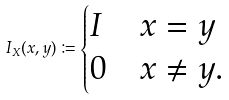<formula> <loc_0><loc_0><loc_500><loc_500>I _ { X } ( x , y ) \coloneqq \begin{cases} I & x = y \\ 0 & x \neq y . \end{cases}</formula> 